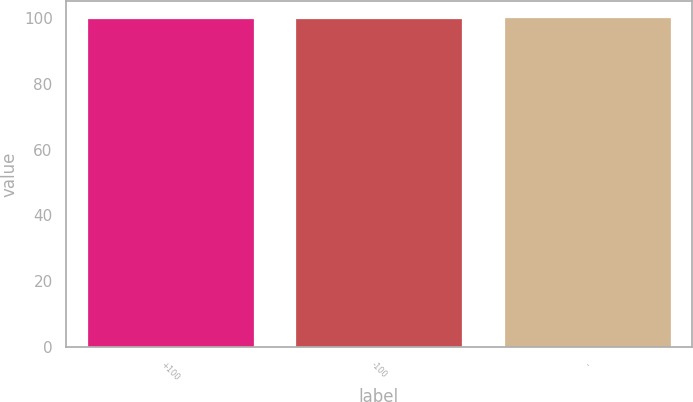Convert chart. <chart><loc_0><loc_0><loc_500><loc_500><bar_chart><fcel>+100<fcel>-100<fcel>-<nl><fcel>100<fcel>100.1<fcel>100.2<nl></chart> 